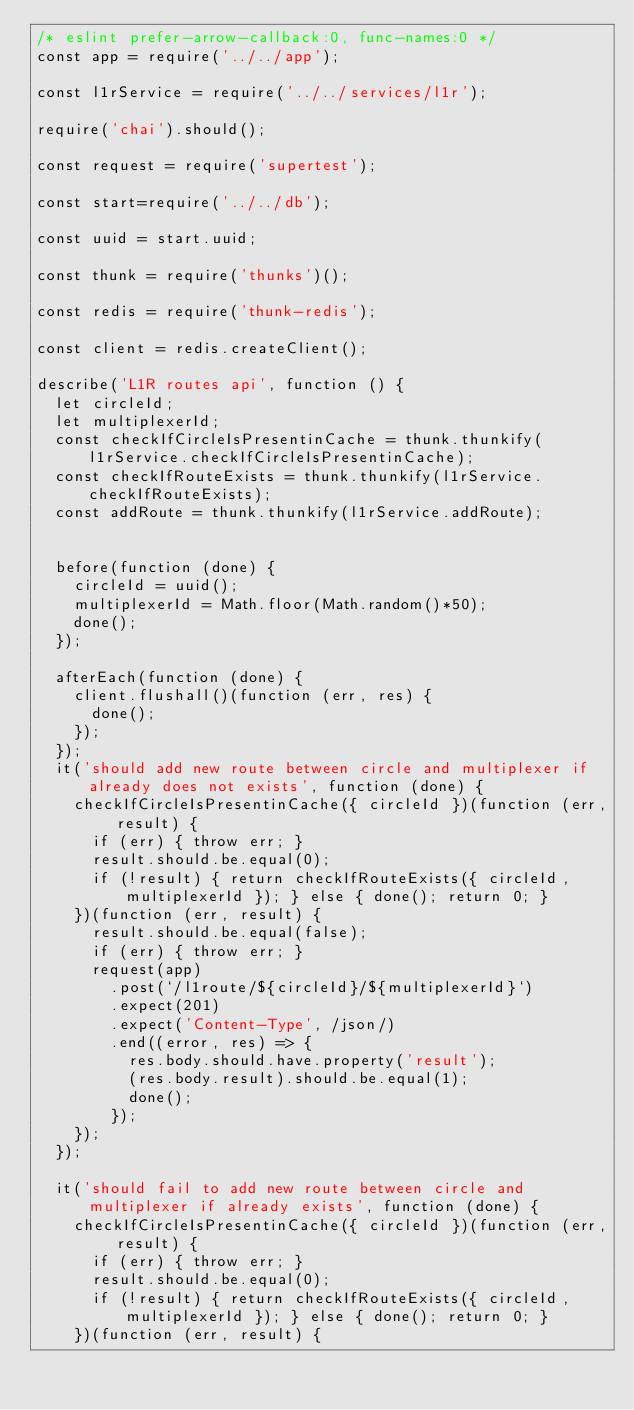<code> <loc_0><loc_0><loc_500><loc_500><_JavaScript_>/* eslint prefer-arrow-callback:0, func-names:0 */
const app = require('../../app');

const l1rService = require('../../services/l1r');

require('chai').should();

const request = require('supertest');

const start=require('../../db');

const uuid = start.uuid;

const thunk = require('thunks')();

const redis = require('thunk-redis');

const client = redis.createClient();

describe('L1R routes api', function () {
  let circleId;
  let multiplexerId;
  const checkIfCircleIsPresentinCache = thunk.thunkify(l1rService.checkIfCircleIsPresentinCache);
  const checkIfRouteExists = thunk.thunkify(l1rService.checkIfRouteExists);
  const addRoute = thunk.thunkify(l1rService.addRoute);


  before(function (done) {
    circleId = uuid();
    multiplexerId = Math.floor(Math.random()*50);
    done();
  });

  afterEach(function (done) {
    client.flushall()(function (err, res) {
      done();
    });
  });
  it('should add new route between circle and multiplexer if already does not exists', function (done) {
    checkIfCircleIsPresentinCache({ circleId })(function (err, result) {
      if (err) { throw err; }
      result.should.be.equal(0);
      if (!result) { return checkIfRouteExists({ circleId, multiplexerId }); } else { done(); return 0; }
    })(function (err, result) {
      result.should.be.equal(false);
      if (err) { throw err; }
      request(app)
        .post(`/l1route/${circleId}/${multiplexerId}`)
        .expect(201)
        .expect('Content-Type', /json/)
        .end((error, res) => {
          res.body.should.have.property('result');
          (res.body.result).should.be.equal(1);
          done();
        });
    });
  });

  it('should fail to add new route between circle and multiplexer if already exists', function (done) {
    checkIfCircleIsPresentinCache({ circleId })(function (err, result) {
      if (err) { throw err; }
      result.should.be.equal(0);
      if (!result) { return checkIfRouteExists({ circleId, multiplexerId }); } else { done(); return 0; }
    })(function (err, result) {</code> 